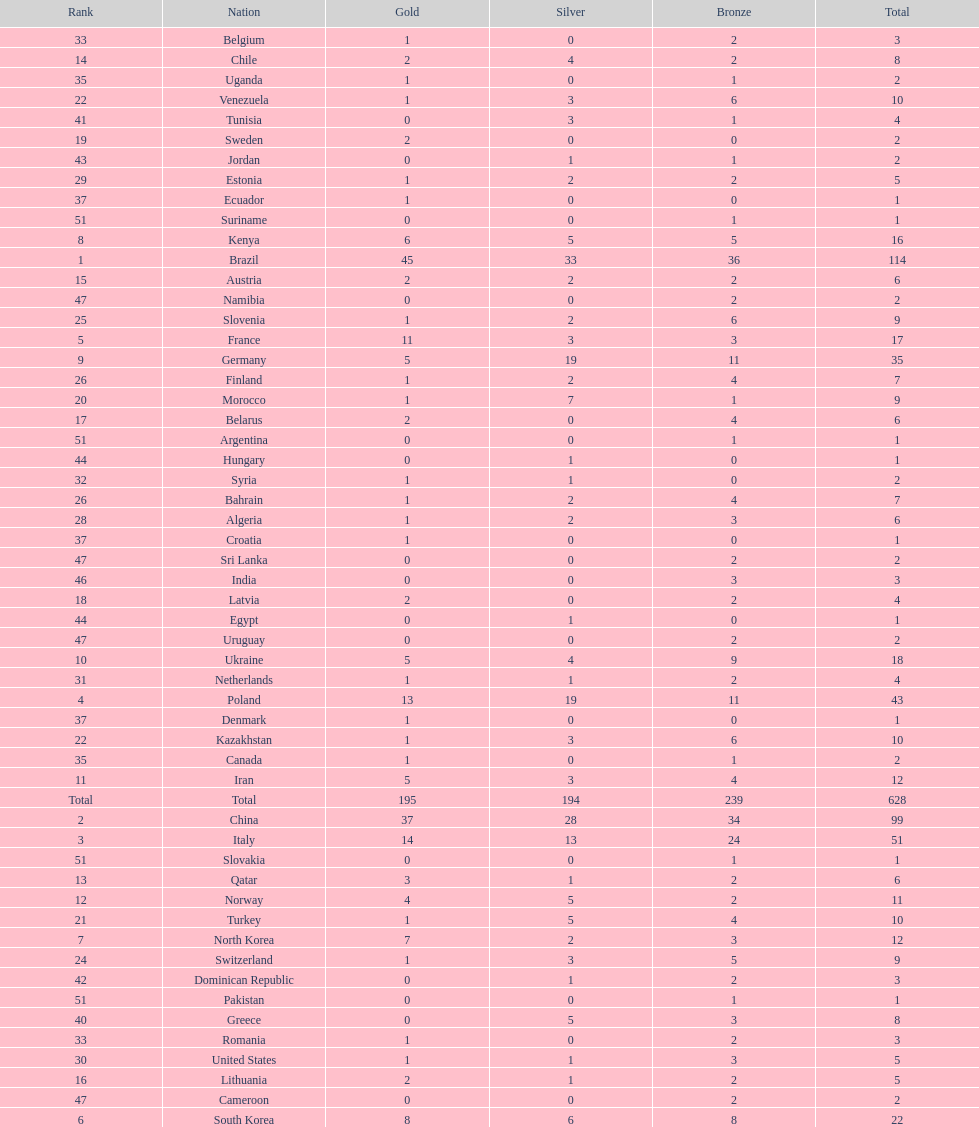How many total medals did norway win? 11. 